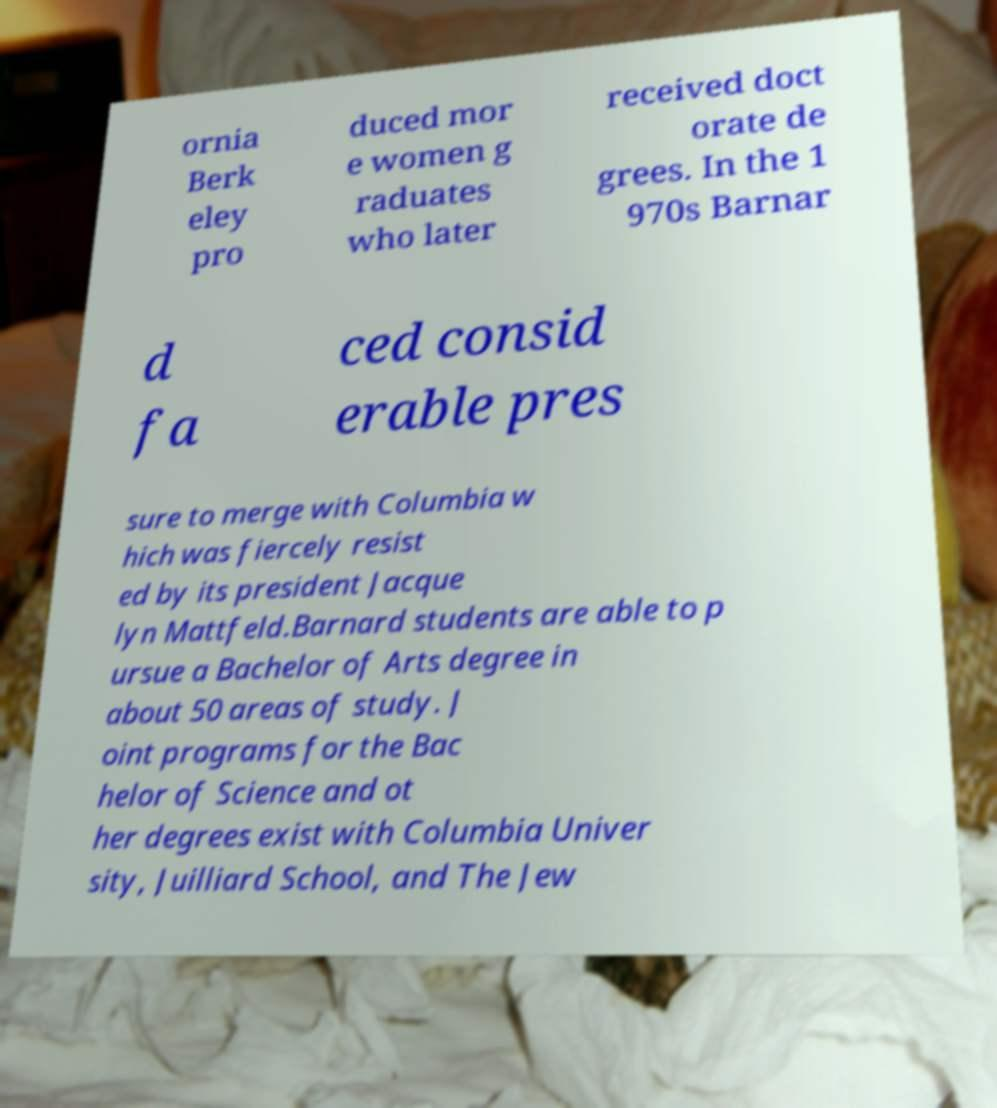There's text embedded in this image that I need extracted. Can you transcribe it verbatim? ornia Berk eley pro duced mor e women g raduates who later received doct orate de grees. In the 1 970s Barnar d fa ced consid erable pres sure to merge with Columbia w hich was fiercely resist ed by its president Jacque lyn Mattfeld.Barnard students are able to p ursue a Bachelor of Arts degree in about 50 areas of study. J oint programs for the Bac helor of Science and ot her degrees exist with Columbia Univer sity, Juilliard School, and The Jew 